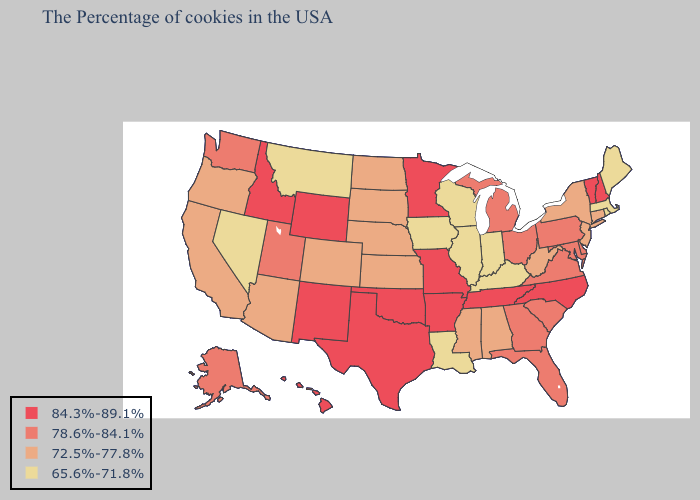Does North Dakota have the highest value in the USA?
Write a very short answer. No. What is the highest value in the South ?
Keep it brief. 84.3%-89.1%. Does Washington have a lower value than Minnesota?
Quick response, please. Yes. Does the map have missing data?
Write a very short answer. No. What is the lowest value in the MidWest?
Answer briefly. 65.6%-71.8%. What is the value of Virginia?
Concise answer only. 78.6%-84.1%. Does Missouri have the highest value in the MidWest?
Concise answer only. Yes. What is the lowest value in the South?
Answer briefly. 65.6%-71.8%. Among the states that border Massachusetts , which have the highest value?
Quick response, please. New Hampshire, Vermont. Among the states that border Indiana , does Michigan have the highest value?
Give a very brief answer. Yes. What is the lowest value in the USA?
Be succinct. 65.6%-71.8%. Name the states that have a value in the range 78.6%-84.1%?
Write a very short answer. Delaware, Maryland, Pennsylvania, Virginia, South Carolina, Ohio, Florida, Georgia, Michigan, Utah, Washington, Alaska. What is the value of Kansas?
Write a very short answer. 72.5%-77.8%. What is the highest value in states that border Maine?
Quick response, please. 84.3%-89.1%. What is the value of Pennsylvania?
Be succinct. 78.6%-84.1%. 